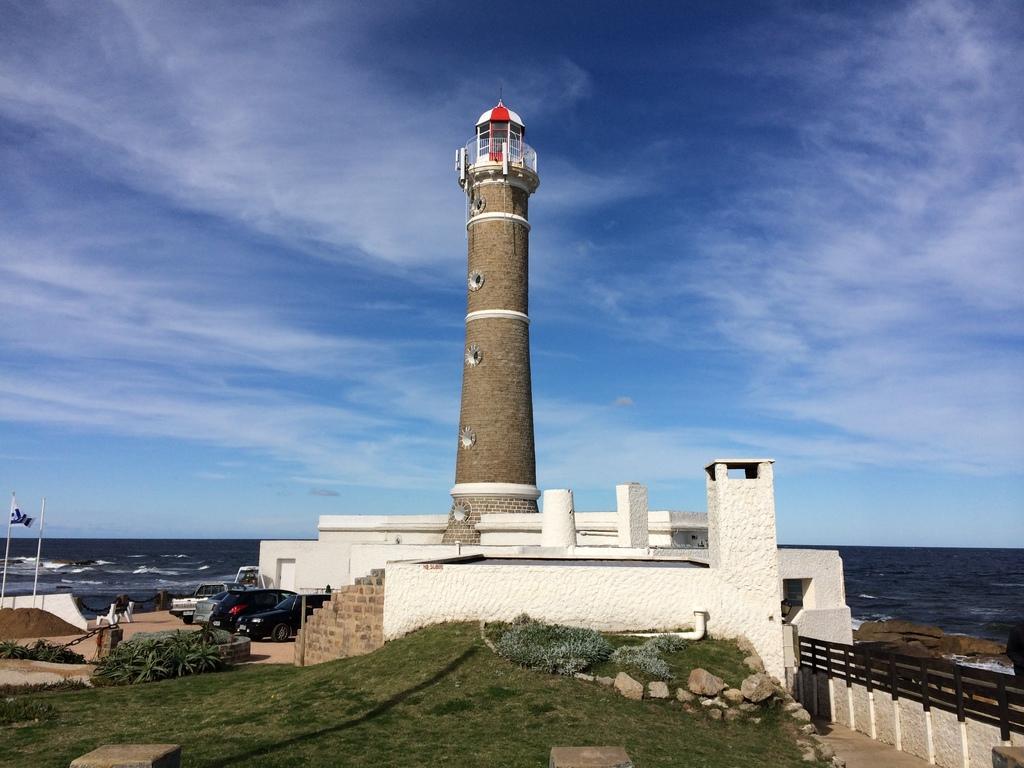Could you give a brief overview of what you see in this image? In this image there is a lighthouse, beside the light house there are cars, in the background there is a sea and a blue sky. 